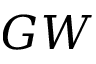Convert formula to latex. <formula><loc_0><loc_0><loc_500><loc_500>G W</formula> 